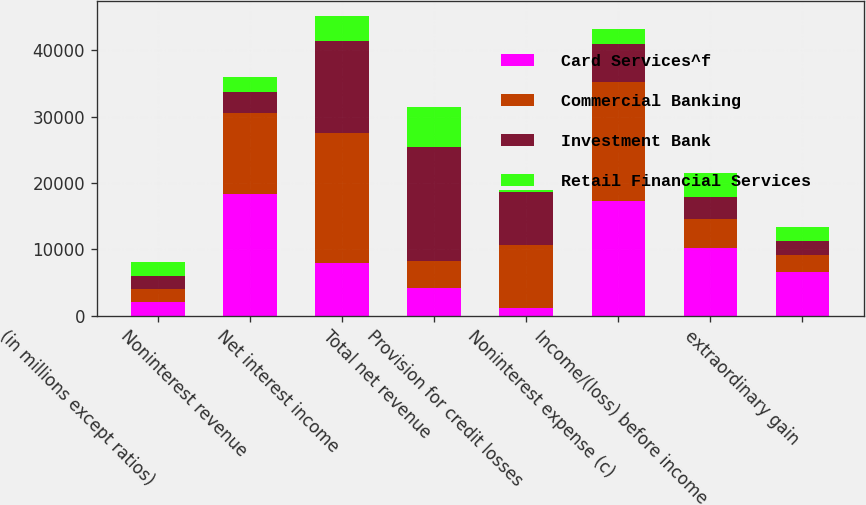Convert chart to OTSL. <chart><loc_0><loc_0><loc_500><loc_500><stacked_bar_chart><ecel><fcel>(in millions except ratios)<fcel>Noninterest revenue<fcel>Net interest income<fcel>Total net revenue<fcel>Provision for credit losses<fcel>Noninterest expense (c)<fcel>Income/(loss) before income<fcel>extraordinary gain<nl><fcel>Card Services^f<fcel>2010<fcel>18253<fcel>7964<fcel>4140<fcel>1200<fcel>17265<fcel>10152<fcel>6639<nl><fcel>Commercial Banking<fcel>2010<fcel>12228<fcel>19528<fcel>4140<fcel>9452<fcel>17864<fcel>4440<fcel>2526<nl><fcel>Investment Bank<fcel>2010<fcel>3277<fcel>13886<fcel>17163<fcel>8037<fcel>5797<fcel>3329<fcel>2074<nl><fcel>Retail Financial Services<fcel>2010<fcel>2200<fcel>3840<fcel>6040<fcel>297<fcel>2199<fcel>3544<fcel>2084<nl></chart> 